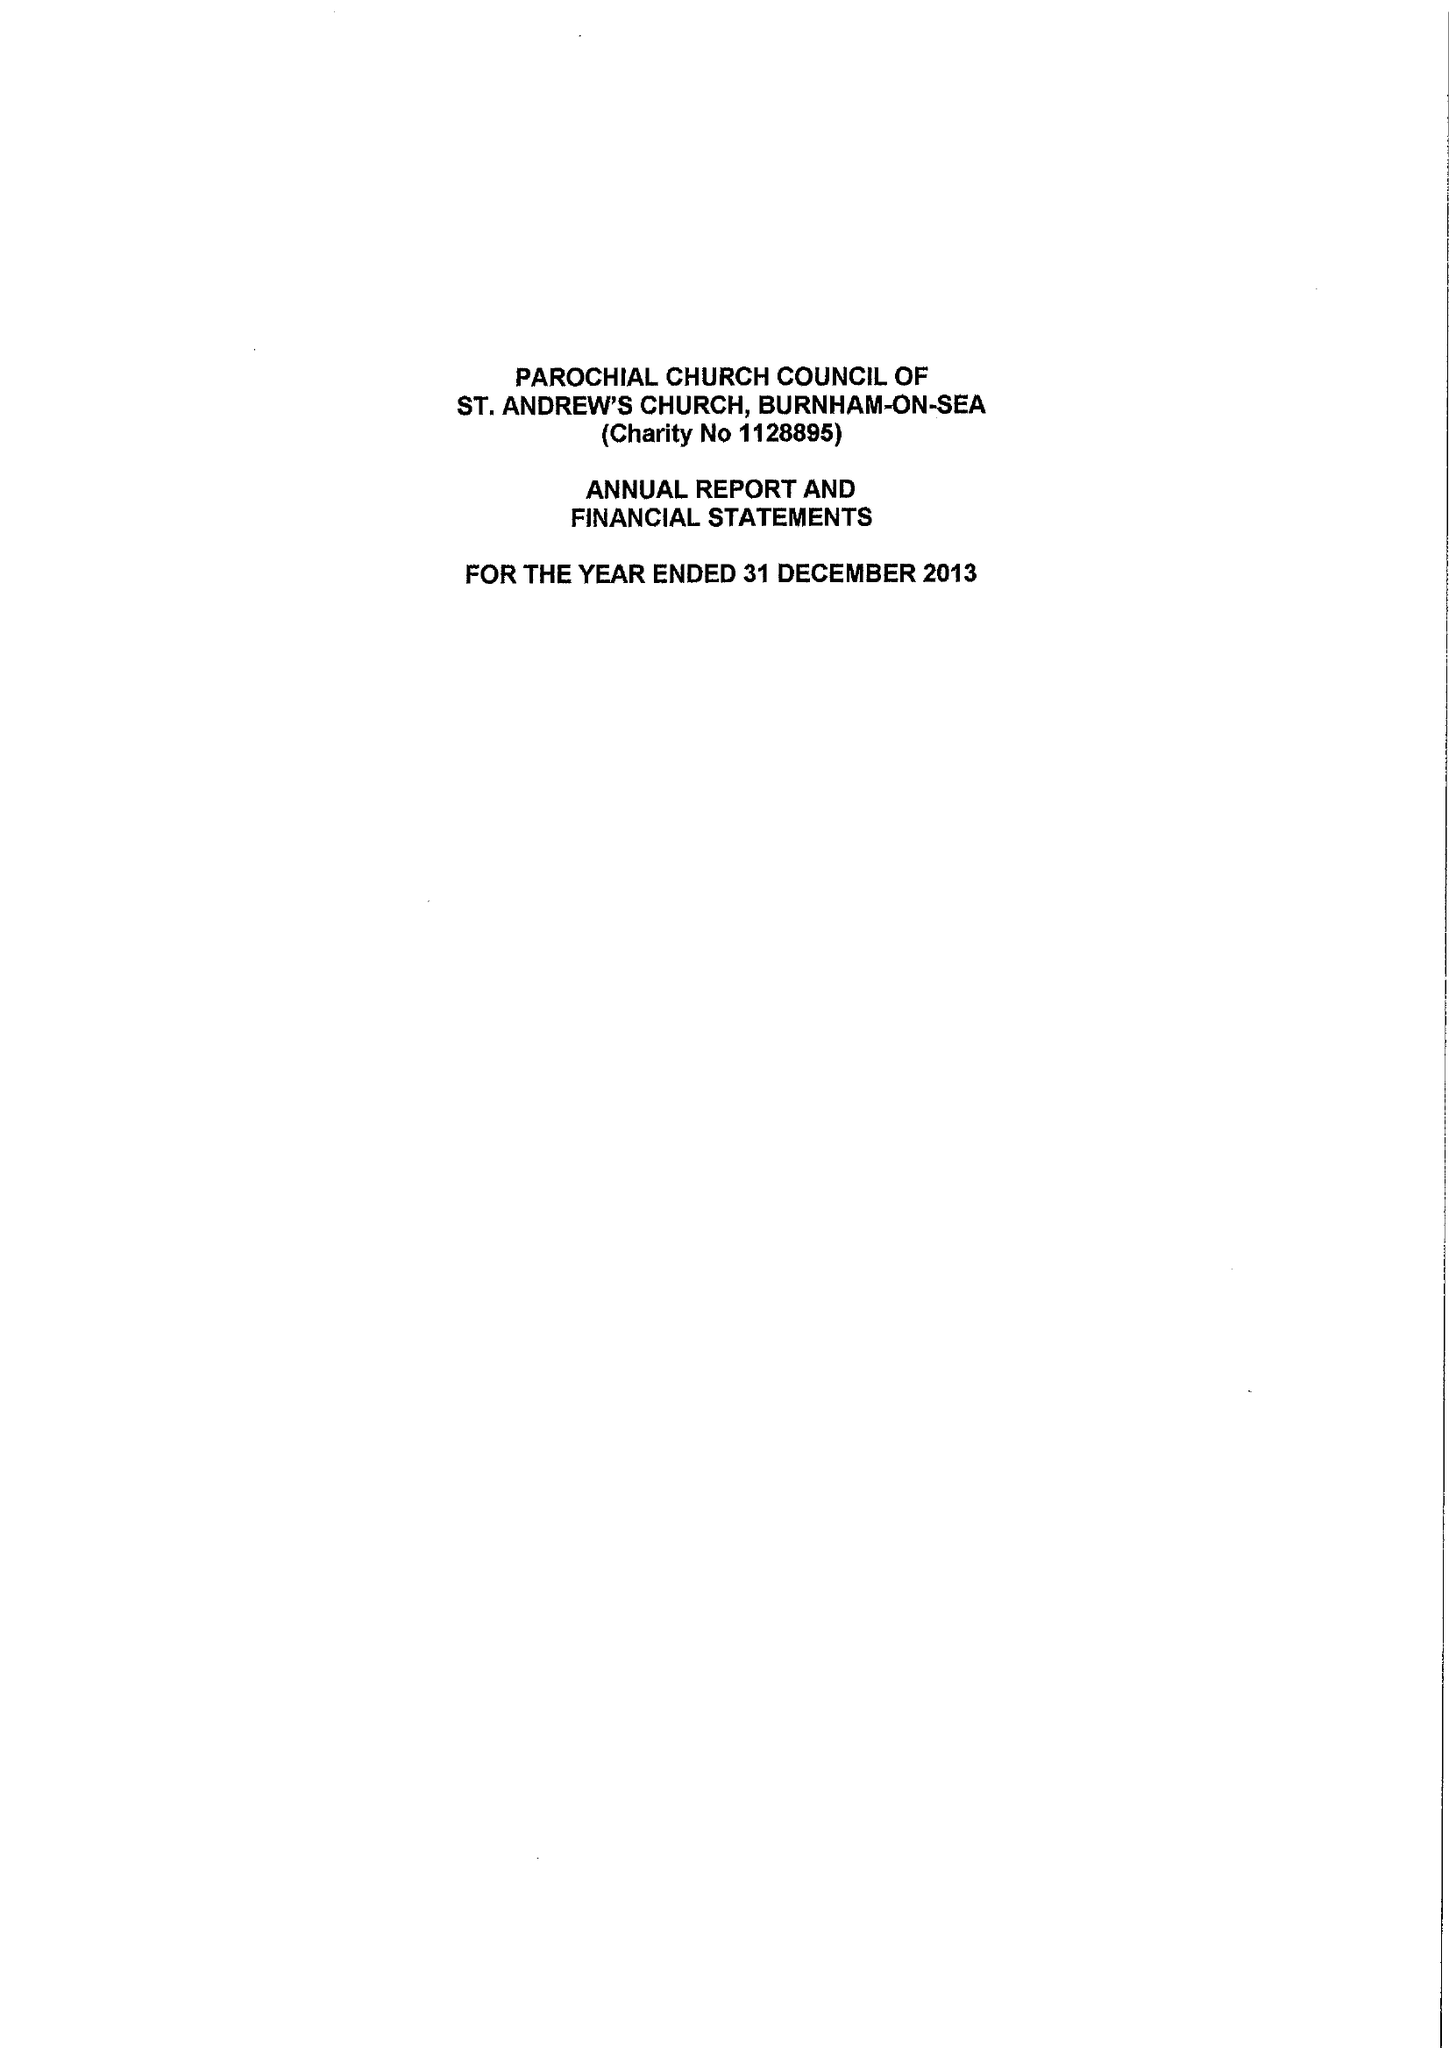What is the value for the address__street_line?
Answer the question using a single word or phrase. 5 CADBURY CLOSE 